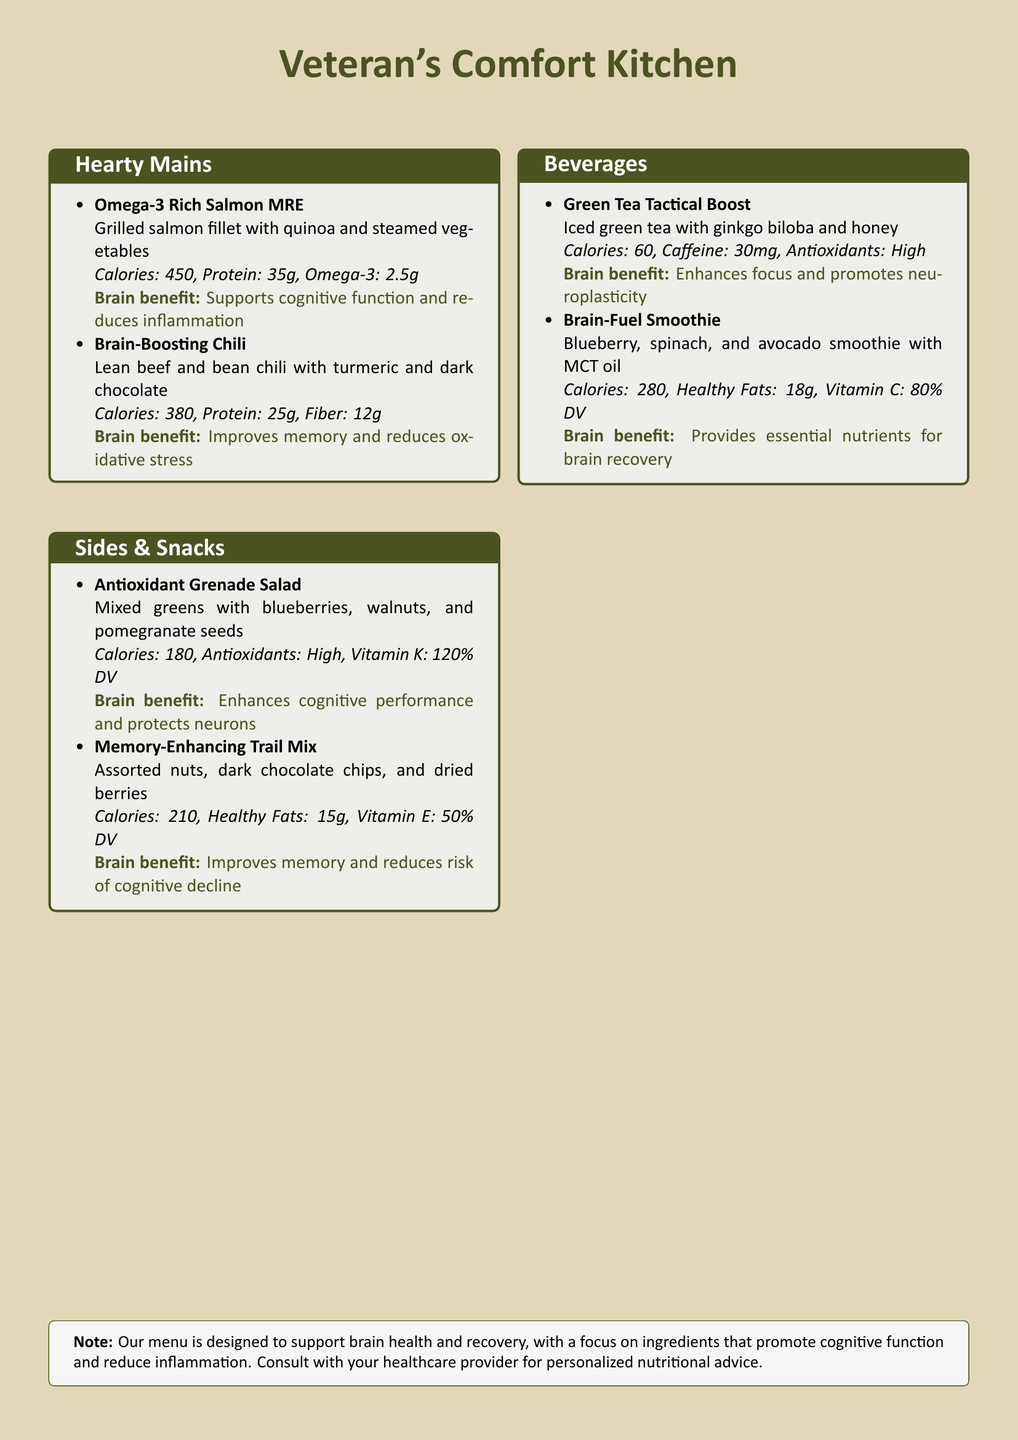What is the main focus of the menu? The menu is designed to support brain health and recovery.
Answer: brain health and recovery How many grams of protein does the Omega-3 Rich Salmon MRE contain? The Omega-3 Rich Salmon MRE lists its protein content in the menu.
Answer: 35g What is the calorie count for the Brain-Boosting Chili? The calorie count is specified for each dish in the menu.
Answer: 380 Which ingredient in the Green Tea Tactical Boost enhances focus? The document mentions ginkgo biloba as a key ingredient.
Answer: ginkgo biloba Which side dish has high antioxidants? The Antioxidant Grenade Salad is highlighted for its high antioxidants.
Answer: Antioxidant Grenade Salad How many grams of healthy fats are in the Memory-Enhancing Trail Mix? The content of healthy fats is provided in the nutritional facts of the dish.
Answer: 15g What is the main benefit of the Brain-Fuel Smoothie? The document states that it provides essential nutrients for brain recovery.
Answer: essential nutrients for brain recovery What type of dietary restriction might someone consider the Note at the bottom? The Note advises consulting healthcare providers for personalized nutritional advice.
Answer: personalized nutritional advice 